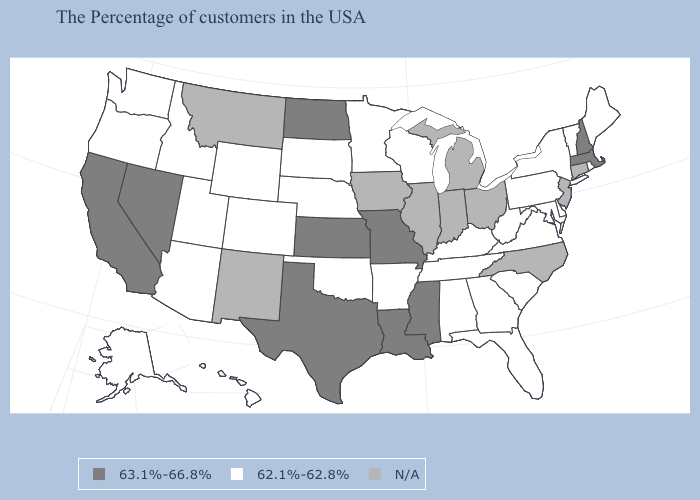What is the value of Tennessee?
Quick response, please. 62.1%-62.8%. Name the states that have a value in the range 63.1%-66.8%?
Keep it brief. Massachusetts, New Hampshire, Mississippi, Louisiana, Missouri, Kansas, Texas, North Dakota, Nevada, California. What is the lowest value in the USA?
Be succinct. 62.1%-62.8%. Which states have the lowest value in the USA?
Write a very short answer. Maine, Rhode Island, Vermont, New York, Delaware, Maryland, Pennsylvania, Virginia, South Carolina, West Virginia, Florida, Georgia, Kentucky, Alabama, Tennessee, Wisconsin, Arkansas, Minnesota, Nebraska, Oklahoma, South Dakota, Wyoming, Colorado, Utah, Arizona, Idaho, Washington, Oregon, Alaska, Hawaii. What is the value of California?
Quick response, please. 63.1%-66.8%. Does Minnesota have the highest value in the USA?
Give a very brief answer. No. What is the value of Ohio?
Give a very brief answer. N/A. Name the states that have a value in the range 62.1%-62.8%?
Be succinct. Maine, Rhode Island, Vermont, New York, Delaware, Maryland, Pennsylvania, Virginia, South Carolina, West Virginia, Florida, Georgia, Kentucky, Alabama, Tennessee, Wisconsin, Arkansas, Minnesota, Nebraska, Oklahoma, South Dakota, Wyoming, Colorado, Utah, Arizona, Idaho, Washington, Oregon, Alaska, Hawaii. Does New Hampshire have the highest value in the Northeast?
Give a very brief answer. Yes. What is the value of Montana?
Short answer required. N/A. Does Maine have the lowest value in the Northeast?
Short answer required. Yes. Does Wisconsin have the lowest value in the USA?
Keep it brief. Yes. Name the states that have a value in the range N/A?
Short answer required. Connecticut, New Jersey, North Carolina, Ohio, Michigan, Indiana, Illinois, Iowa, New Mexico, Montana. 